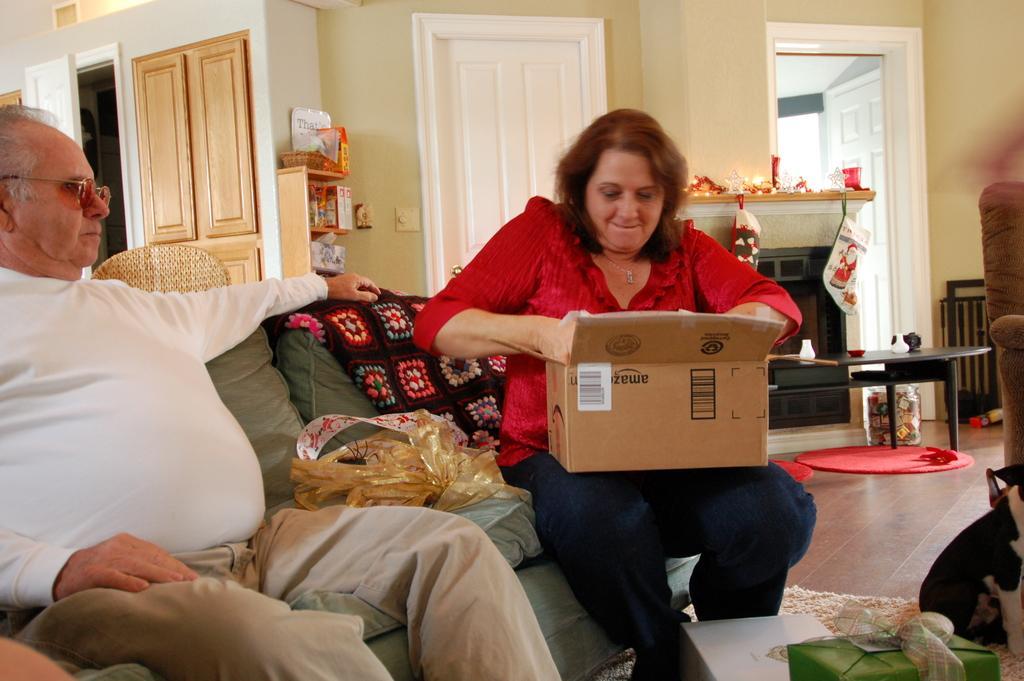Could you give a brief overview of what you see in this image? In the picture I can see a woman wearing red color dress is sitting on the sofa by holding a cardboard box. On the left side of the image, we can see a person wearing white color T-shirt and spectacles is sitting on the sofa. Here we can see a few objects, we can see a table, fireplace, some decorative items, doors, chair and the wall in the background. 